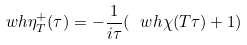<formula> <loc_0><loc_0><loc_500><loc_500>\ w h { \eta _ { T } ^ { + } } ( \tau ) = - \frac { 1 } { i \tau } ( \ w h { \chi } ( T \tau ) + 1 )</formula> 